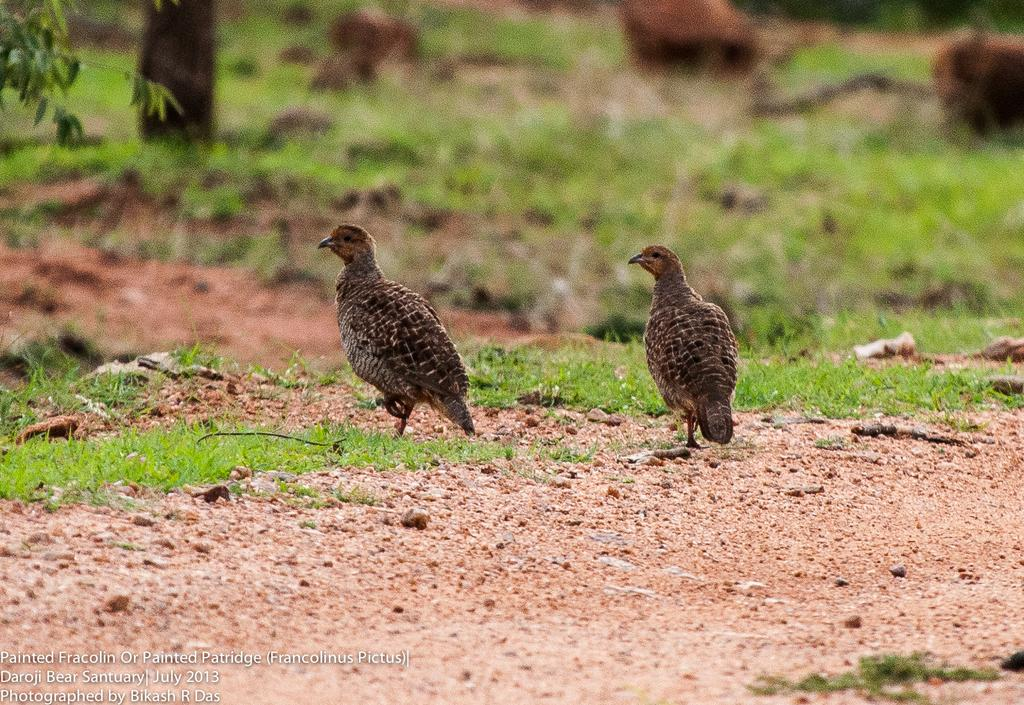What type of animals can be seen in the image? There are birds in the image. What type of vegetation is present in the image? There is grass in the image. How would you describe the background of the image? The background of the image is blurred and green. What channel is the snake watching on TV in the image? There is no TV or snake present in the image. 